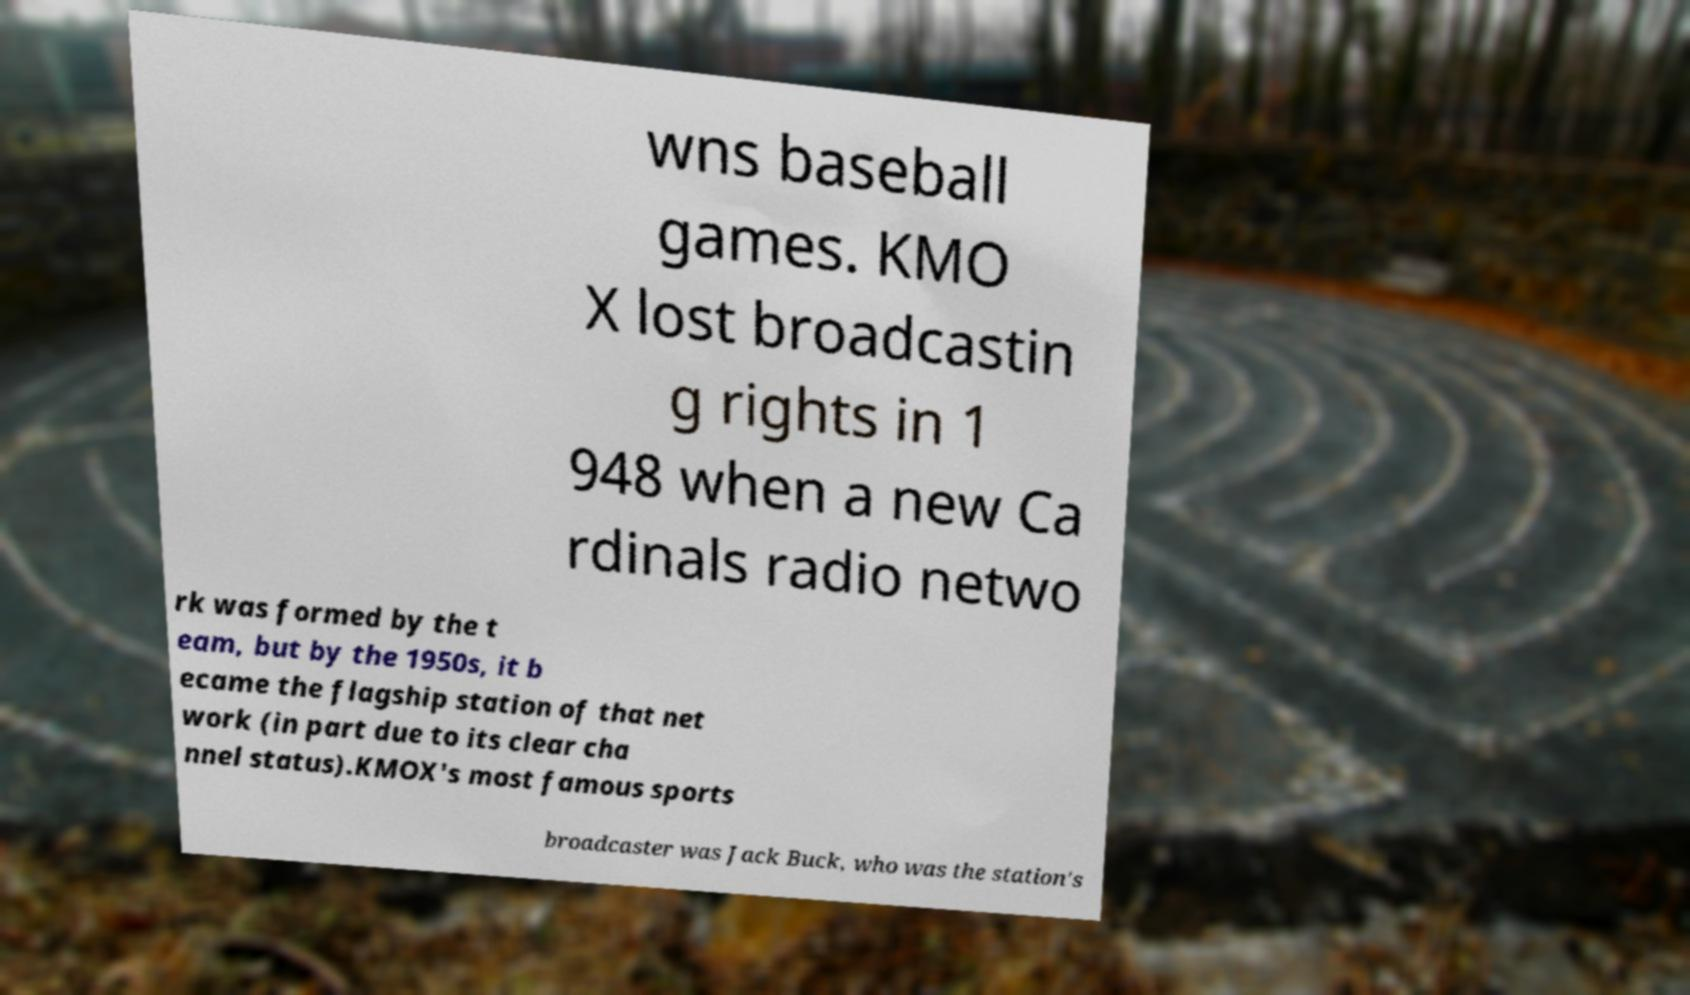Can you accurately transcribe the text from the provided image for me? wns baseball games. KMO X lost broadcastin g rights in 1 948 when a new Ca rdinals radio netwo rk was formed by the t eam, but by the 1950s, it b ecame the flagship station of that net work (in part due to its clear cha nnel status).KMOX's most famous sports broadcaster was Jack Buck, who was the station's 